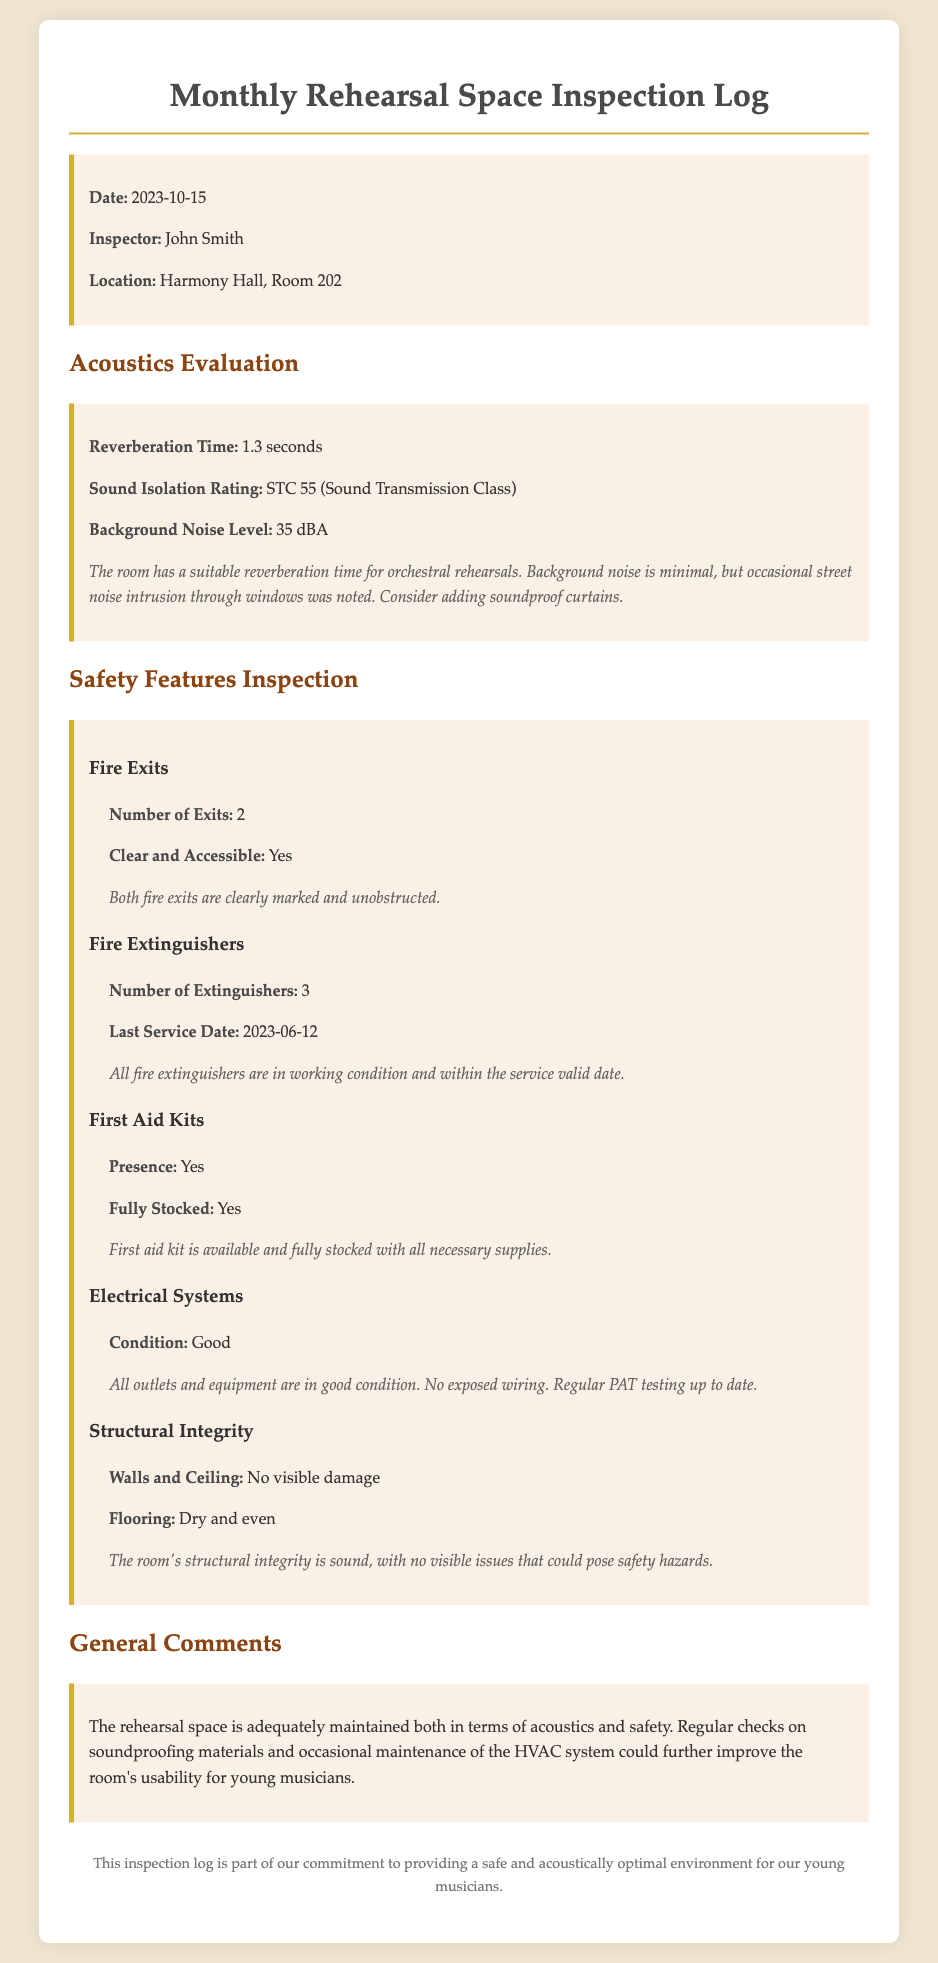What is the date of the inspection? The date of the inspection is specified at the beginning of the document.
Answer: 2023-10-15 Who conducted the inspection? The name of the inspector is provided under the inspector's section.
Answer: John Smith What is the reverberation time reported? The reverberation time for the rehearsal space is detailed in the acoustics evaluation section.
Answer: 1.3 seconds How many fire exits are there? The number of fire exits is listed in the safety features inspection section.
Answer: 2 What is the sound isolation rating? The sound isolation rating is mentioned under the acoustics evaluation section.
Answer: STC 55 Are the fire extinguishers in working condition? The comment regarding the fire extinguishers indicates their condition.
Answer: Yes What is the background noise level? The background noise level is a specific measurement in the acoustics evaluation.
Answer: 35 dBA Is the first aid kit fully stocked? The condition of the first aid kit is mentioned under its corresponding subsection.
Answer: Yes What additional maintenance suggestion is noted? General comments include proposals for improving the rehearsal space's usability.
Answer: Soundproofing materials 